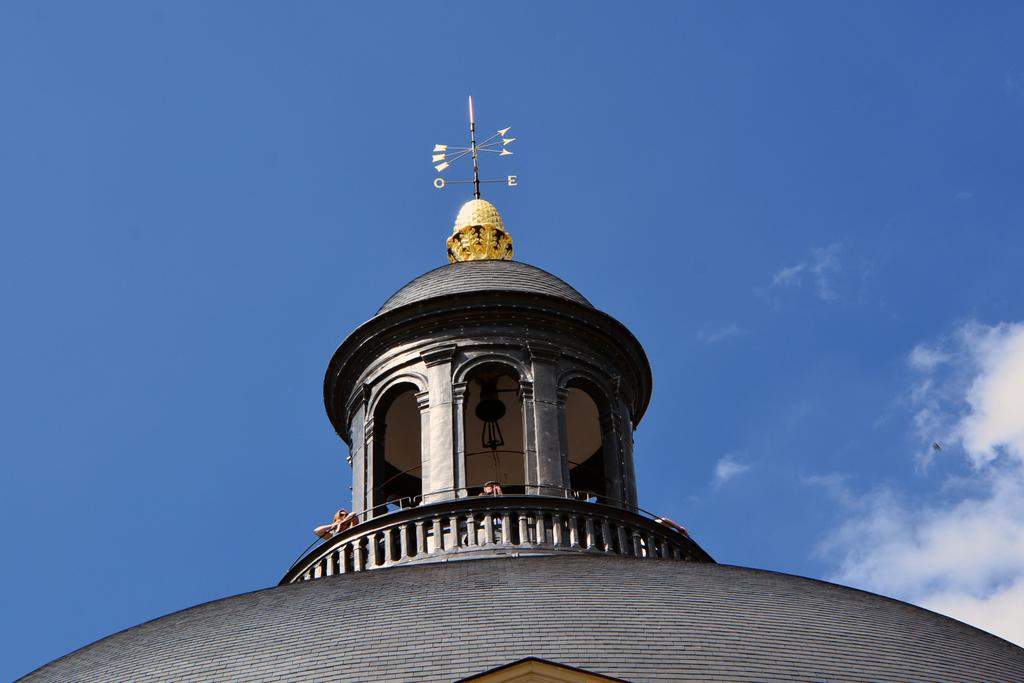What is the main structure in the image? There is a tomb in the image. What is written or depicted above the tomb? There are directions above the tomb. What can be seen at the top of the image? The sky is visible at the top of the image. Are there any people present in the image? Yes, there are people standing under the tomb. What type of pleasure can be heard coming from the bedroom in the image? There is no bedroom or pleasure mentioned in the image; it features a tomb with directions and people standing under it. 